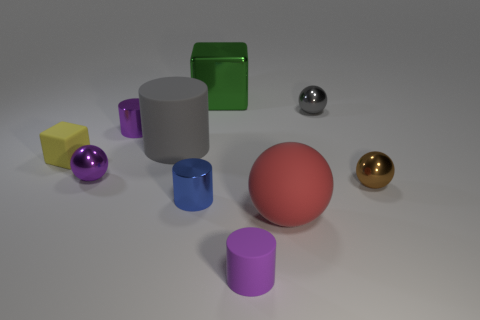What number of other things are made of the same material as the big gray cylinder?
Keep it short and to the point. 3. The gray object in front of the small metallic ball behind the small yellow block is what shape?
Your answer should be compact. Cylinder. How big is the cylinder right of the large green metallic cube?
Ensure brevity in your answer.  Small. Is the material of the small purple sphere the same as the red object?
Make the answer very short. No. What is the shape of the big red object that is the same material as the yellow thing?
Offer a terse response. Sphere. Is there anything else that has the same color as the rubber block?
Offer a terse response. No. There is a tiny metal cylinder in front of the small yellow thing; what is its color?
Your response must be concise. Blue. There is a metallic sphere behind the tiny yellow rubber cube; is its color the same as the rubber sphere?
Offer a terse response. No. What is the material of the other large thing that is the same shape as the gray shiny thing?
Your answer should be very brief. Rubber. How many yellow rubber things have the same size as the matte sphere?
Your answer should be compact. 0. 